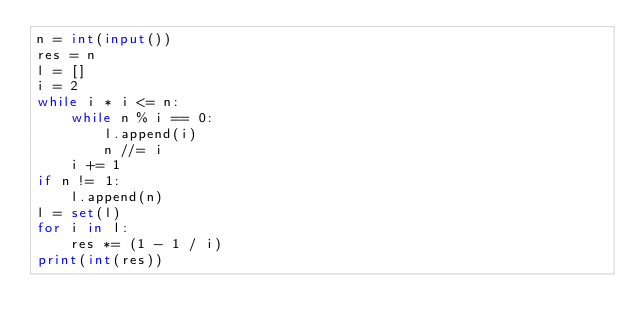Convert code to text. <code><loc_0><loc_0><loc_500><loc_500><_Python_>n = int(input())
res = n
l = []
i = 2
while i * i <= n:
    while n % i == 0:
        l.append(i)
        n //= i
    i += 1
if n != 1:
    l.append(n)
l = set(l)
for i in l:
    res *= (1 - 1 / i)
print(int(res))

</code> 